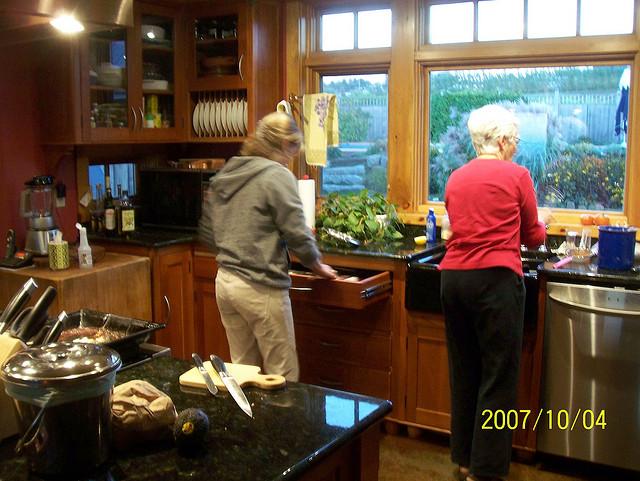How many knives are on the cutting board?
Short answer required. 2. How many women are in the kitchen?
Quick response, please. 2. When was the photo taken?
Keep it brief. 2007/10/04. What color shirt is the woman on the right wearing?
Quick response, please. Red. Is dinner served?
Give a very brief answer. No. 